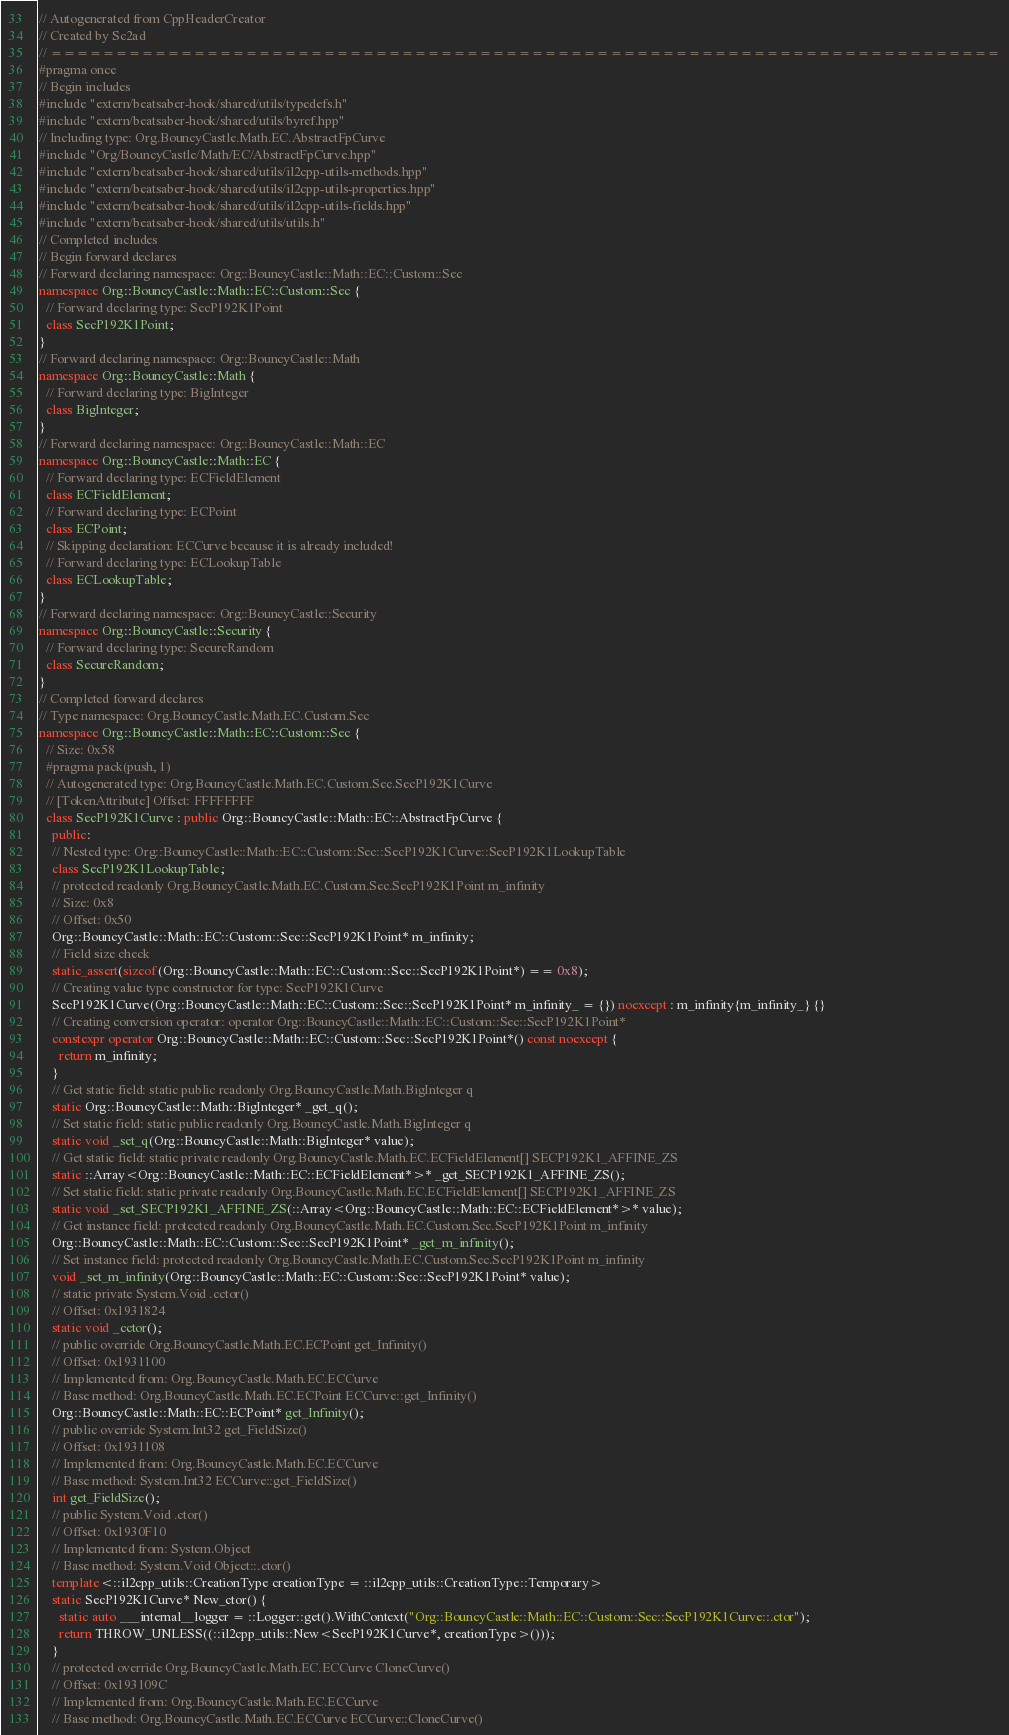<code> <loc_0><loc_0><loc_500><loc_500><_C++_>// Autogenerated from CppHeaderCreator
// Created by Sc2ad
// =========================================================================
#pragma once
// Begin includes
#include "extern/beatsaber-hook/shared/utils/typedefs.h"
#include "extern/beatsaber-hook/shared/utils/byref.hpp"
// Including type: Org.BouncyCastle.Math.EC.AbstractFpCurve
#include "Org/BouncyCastle/Math/EC/AbstractFpCurve.hpp"
#include "extern/beatsaber-hook/shared/utils/il2cpp-utils-methods.hpp"
#include "extern/beatsaber-hook/shared/utils/il2cpp-utils-properties.hpp"
#include "extern/beatsaber-hook/shared/utils/il2cpp-utils-fields.hpp"
#include "extern/beatsaber-hook/shared/utils/utils.h"
// Completed includes
// Begin forward declares
// Forward declaring namespace: Org::BouncyCastle::Math::EC::Custom::Sec
namespace Org::BouncyCastle::Math::EC::Custom::Sec {
  // Forward declaring type: SecP192K1Point
  class SecP192K1Point;
}
// Forward declaring namespace: Org::BouncyCastle::Math
namespace Org::BouncyCastle::Math {
  // Forward declaring type: BigInteger
  class BigInteger;
}
// Forward declaring namespace: Org::BouncyCastle::Math::EC
namespace Org::BouncyCastle::Math::EC {
  // Forward declaring type: ECFieldElement
  class ECFieldElement;
  // Forward declaring type: ECPoint
  class ECPoint;
  // Skipping declaration: ECCurve because it is already included!
  // Forward declaring type: ECLookupTable
  class ECLookupTable;
}
// Forward declaring namespace: Org::BouncyCastle::Security
namespace Org::BouncyCastle::Security {
  // Forward declaring type: SecureRandom
  class SecureRandom;
}
// Completed forward declares
// Type namespace: Org.BouncyCastle.Math.EC.Custom.Sec
namespace Org::BouncyCastle::Math::EC::Custom::Sec {
  // Size: 0x58
  #pragma pack(push, 1)
  // Autogenerated type: Org.BouncyCastle.Math.EC.Custom.Sec.SecP192K1Curve
  // [TokenAttribute] Offset: FFFFFFFF
  class SecP192K1Curve : public Org::BouncyCastle::Math::EC::AbstractFpCurve {
    public:
    // Nested type: Org::BouncyCastle::Math::EC::Custom::Sec::SecP192K1Curve::SecP192K1LookupTable
    class SecP192K1LookupTable;
    // protected readonly Org.BouncyCastle.Math.EC.Custom.Sec.SecP192K1Point m_infinity
    // Size: 0x8
    // Offset: 0x50
    Org::BouncyCastle::Math::EC::Custom::Sec::SecP192K1Point* m_infinity;
    // Field size check
    static_assert(sizeof(Org::BouncyCastle::Math::EC::Custom::Sec::SecP192K1Point*) == 0x8);
    // Creating value type constructor for type: SecP192K1Curve
    SecP192K1Curve(Org::BouncyCastle::Math::EC::Custom::Sec::SecP192K1Point* m_infinity_ = {}) noexcept : m_infinity{m_infinity_} {}
    // Creating conversion operator: operator Org::BouncyCastle::Math::EC::Custom::Sec::SecP192K1Point*
    constexpr operator Org::BouncyCastle::Math::EC::Custom::Sec::SecP192K1Point*() const noexcept {
      return m_infinity;
    }
    // Get static field: static public readonly Org.BouncyCastle.Math.BigInteger q
    static Org::BouncyCastle::Math::BigInteger* _get_q();
    // Set static field: static public readonly Org.BouncyCastle.Math.BigInteger q
    static void _set_q(Org::BouncyCastle::Math::BigInteger* value);
    // Get static field: static private readonly Org.BouncyCastle.Math.EC.ECFieldElement[] SECP192K1_AFFINE_ZS
    static ::Array<Org::BouncyCastle::Math::EC::ECFieldElement*>* _get_SECP192K1_AFFINE_ZS();
    // Set static field: static private readonly Org.BouncyCastle.Math.EC.ECFieldElement[] SECP192K1_AFFINE_ZS
    static void _set_SECP192K1_AFFINE_ZS(::Array<Org::BouncyCastle::Math::EC::ECFieldElement*>* value);
    // Get instance field: protected readonly Org.BouncyCastle.Math.EC.Custom.Sec.SecP192K1Point m_infinity
    Org::BouncyCastle::Math::EC::Custom::Sec::SecP192K1Point* _get_m_infinity();
    // Set instance field: protected readonly Org.BouncyCastle.Math.EC.Custom.Sec.SecP192K1Point m_infinity
    void _set_m_infinity(Org::BouncyCastle::Math::EC::Custom::Sec::SecP192K1Point* value);
    // static private System.Void .cctor()
    // Offset: 0x1931824
    static void _cctor();
    // public override Org.BouncyCastle.Math.EC.ECPoint get_Infinity()
    // Offset: 0x1931100
    // Implemented from: Org.BouncyCastle.Math.EC.ECCurve
    // Base method: Org.BouncyCastle.Math.EC.ECPoint ECCurve::get_Infinity()
    Org::BouncyCastle::Math::EC::ECPoint* get_Infinity();
    // public override System.Int32 get_FieldSize()
    // Offset: 0x1931108
    // Implemented from: Org.BouncyCastle.Math.EC.ECCurve
    // Base method: System.Int32 ECCurve::get_FieldSize()
    int get_FieldSize();
    // public System.Void .ctor()
    // Offset: 0x1930F10
    // Implemented from: System.Object
    // Base method: System.Void Object::.ctor()
    template<::il2cpp_utils::CreationType creationType = ::il2cpp_utils::CreationType::Temporary>
    static SecP192K1Curve* New_ctor() {
      static auto ___internal__logger = ::Logger::get().WithContext("Org::BouncyCastle::Math::EC::Custom::Sec::SecP192K1Curve::.ctor");
      return THROW_UNLESS((::il2cpp_utils::New<SecP192K1Curve*, creationType>()));
    }
    // protected override Org.BouncyCastle.Math.EC.ECCurve CloneCurve()
    // Offset: 0x193109C
    // Implemented from: Org.BouncyCastle.Math.EC.ECCurve
    // Base method: Org.BouncyCastle.Math.EC.ECCurve ECCurve::CloneCurve()</code> 